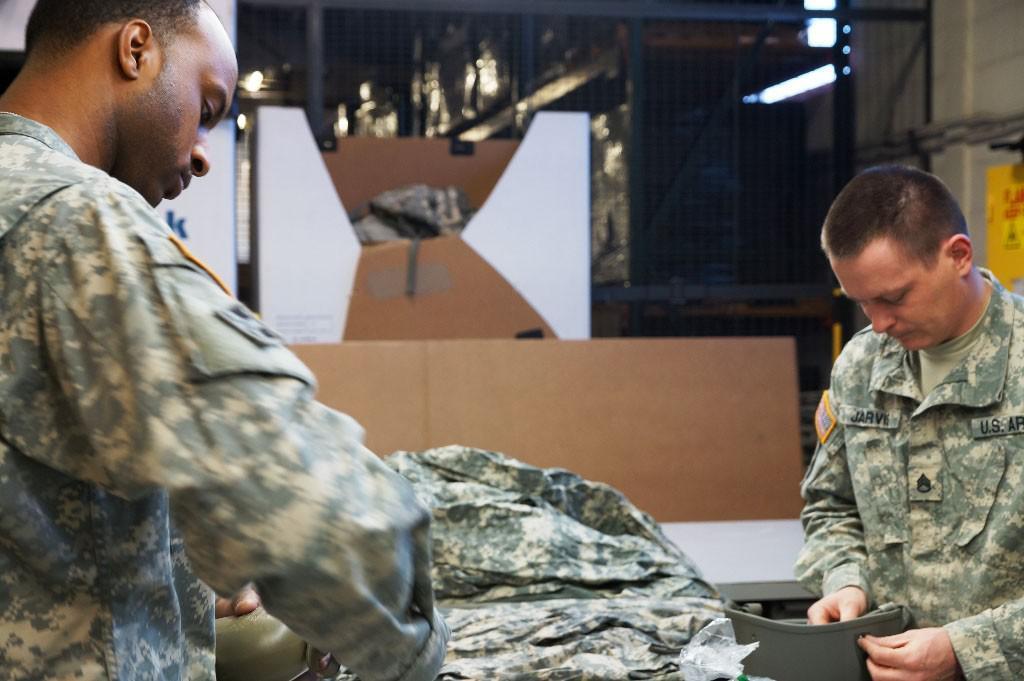How would you summarize this image in a sentence or two? In this picture there are two men holding objects and we can see cloth, boards and objects. In the background of the image we can see mesh and lights. 